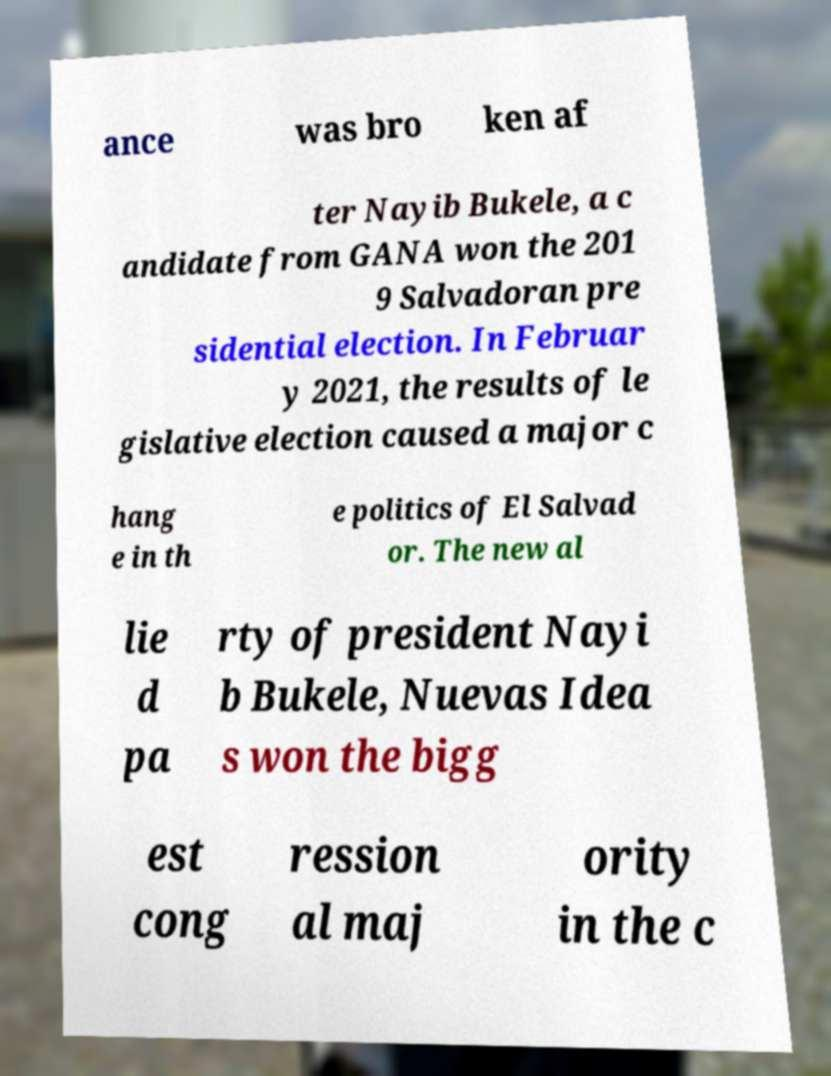Please read and relay the text visible in this image. What does it say? ance was bro ken af ter Nayib Bukele, a c andidate from GANA won the 201 9 Salvadoran pre sidential election. In Februar y 2021, the results of le gislative election caused a major c hang e in th e politics of El Salvad or. The new al lie d pa rty of president Nayi b Bukele, Nuevas Idea s won the bigg est cong ression al maj ority in the c 